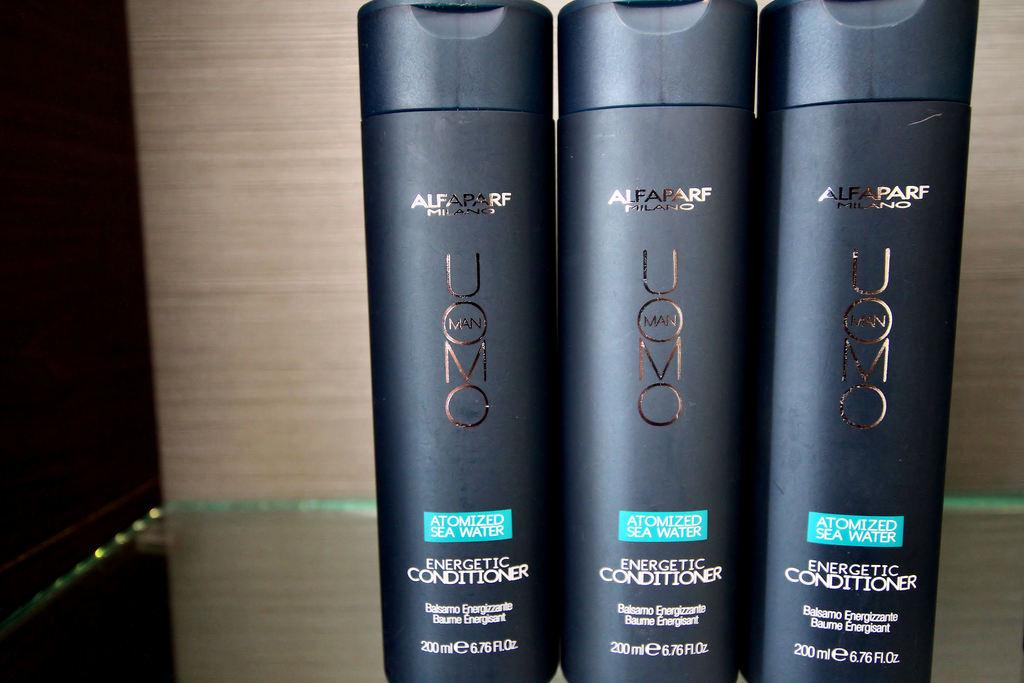<image>
Create a compact narrative representing the image presented. Three bottles of conditioner sit on a shelf. 